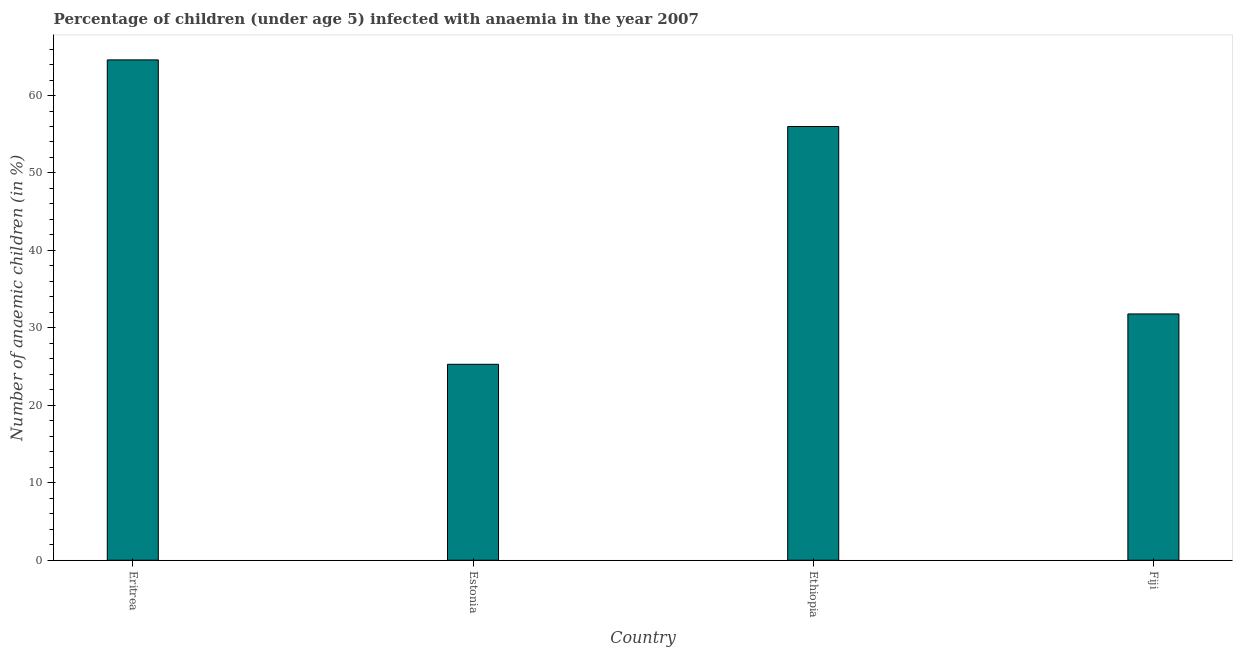Does the graph contain any zero values?
Your answer should be compact. No. Does the graph contain grids?
Offer a terse response. No. What is the title of the graph?
Your answer should be very brief. Percentage of children (under age 5) infected with anaemia in the year 2007. What is the label or title of the X-axis?
Your response must be concise. Country. What is the label or title of the Y-axis?
Provide a short and direct response. Number of anaemic children (in %). What is the number of anaemic children in Ethiopia?
Offer a very short reply. 56. Across all countries, what is the maximum number of anaemic children?
Offer a very short reply. 64.6. Across all countries, what is the minimum number of anaemic children?
Your answer should be compact. 25.3. In which country was the number of anaemic children maximum?
Keep it short and to the point. Eritrea. In which country was the number of anaemic children minimum?
Make the answer very short. Estonia. What is the sum of the number of anaemic children?
Keep it short and to the point. 177.7. What is the difference between the number of anaemic children in Estonia and Fiji?
Provide a succinct answer. -6.5. What is the average number of anaemic children per country?
Make the answer very short. 44.42. What is the median number of anaemic children?
Keep it short and to the point. 43.9. What is the ratio of the number of anaemic children in Estonia to that in Fiji?
Your response must be concise. 0.8. Is the number of anaemic children in Eritrea less than that in Estonia?
Provide a succinct answer. No. Is the difference between the number of anaemic children in Ethiopia and Fiji greater than the difference between any two countries?
Provide a succinct answer. No. What is the difference between the highest and the second highest number of anaemic children?
Offer a terse response. 8.6. What is the difference between the highest and the lowest number of anaemic children?
Provide a short and direct response. 39.3. How many bars are there?
Your answer should be very brief. 4. How many countries are there in the graph?
Your answer should be very brief. 4. Are the values on the major ticks of Y-axis written in scientific E-notation?
Give a very brief answer. No. What is the Number of anaemic children (in %) of Eritrea?
Offer a terse response. 64.6. What is the Number of anaemic children (in %) of Estonia?
Provide a succinct answer. 25.3. What is the Number of anaemic children (in %) in Ethiopia?
Your response must be concise. 56. What is the Number of anaemic children (in %) in Fiji?
Offer a terse response. 31.8. What is the difference between the Number of anaemic children (in %) in Eritrea and Estonia?
Your response must be concise. 39.3. What is the difference between the Number of anaemic children (in %) in Eritrea and Ethiopia?
Keep it short and to the point. 8.6. What is the difference between the Number of anaemic children (in %) in Eritrea and Fiji?
Your answer should be very brief. 32.8. What is the difference between the Number of anaemic children (in %) in Estonia and Ethiopia?
Provide a succinct answer. -30.7. What is the difference between the Number of anaemic children (in %) in Ethiopia and Fiji?
Keep it short and to the point. 24.2. What is the ratio of the Number of anaemic children (in %) in Eritrea to that in Estonia?
Make the answer very short. 2.55. What is the ratio of the Number of anaemic children (in %) in Eritrea to that in Ethiopia?
Your answer should be compact. 1.15. What is the ratio of the Number of anaemic children (in %) in Eritrea to that in Fiji?
Keep it short and to the point. 2.03. What is the ratio of the Number of anaemic children (in %) in Estonia to that in Ethiopia?
Provide a succinct answer. 0.45. What is the ratio of the Number of anaemic children (in %) in Estonia to that in Fiji?
Provide a succinct answer. 0.8. What is the ratio of the Number of anaemic children (in %) in Ethiopia to that in Fiji?
Provide a short and direct response. 1.76. 